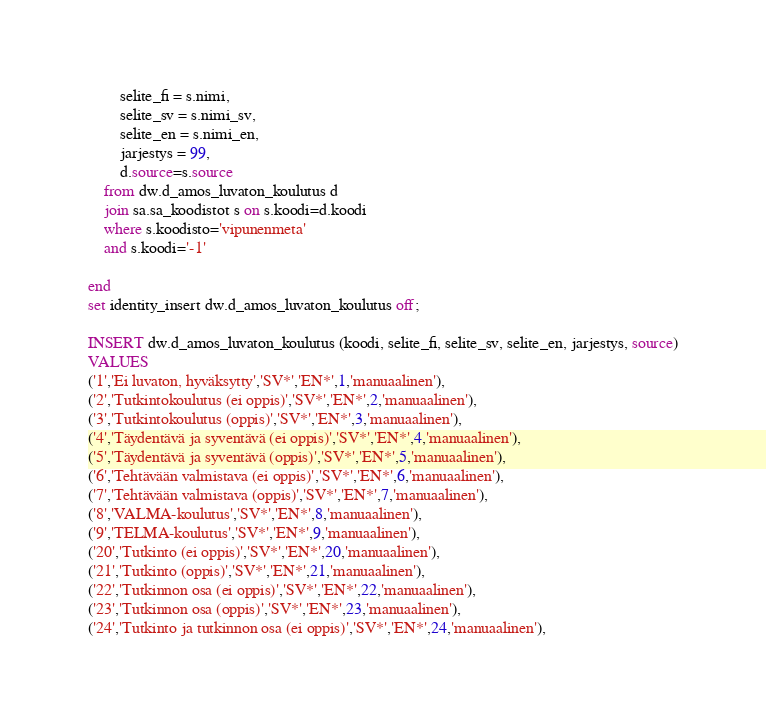<code> <loc_0><loc_0><loc_500><loc_500><_SQL_>		selite_fi = s.nimi,
		selite_sv = s.nimi_sv,
		selite_en = s.nimi_en,
		jarjestys = 99,
		d.source=s.source
	from dw.d_amos_luvaton_koulutus d
	join sa.sa_koodistot s on s.koodi=d.koodi
	where s.koodisto='vipunenmeta'
	and s.koodi='-1'

end
set identity_insert dw.d_amos_luvaton_koulutus off;

INSERT dw.d_amos_luvaton_koulutus (koodi, selite_fi, selite_sv, selite_en, jarjestys, source)
VALUES 
('1','Ei luvaton, hyväksytty','SV*','EN*',1,'manuaalinen'),
('2','Tutkintokoulutus (ei oppis)','SV*','EN*',2,'manuaalinen'),
('3','Tutkintokoulutus (oppis)','SV*','EN*',3,'manuaalinen'),
('4','Täydentävä ja syventävä (ei oppis)','SV*','EN*',4,'manuaalinen'),
('5','Täydentävä ja syventävä (oppis)','SV*','EN*',5,'manuaalinen'),
('6','Tehtävään valmistava (ei oppis)','SV*','EN*',6,'manuaalinen'),
('7','Tehtävään valmistava (oppis)','SV*','EN*',7,'manuaalinen'),
('8','VALMA-koulutus','SV*','EN*',8,'manuaalinen'),
('9','TELMA-koulutus','SV*','EN*',9,'manuaalinen'),
('20','Tutkinto (ei oppis)','SV*','EN*',20,'manuaalinen'),
('21','Tutkinto (oppis)','SV*','EN*',21,'manuaalinen'),
('22','Tutkinnon osa (ei oppis)','SV*','EN*',22,'manuaalinen'),
('23','Tutkinnon osa (oppis)','SV*','EN*',23,'manuaalinen'),
('24','Tutkinto ja tutkinnon osa (ei oppis)','SV*','EN*',24,'manuaalinen'),</code> 